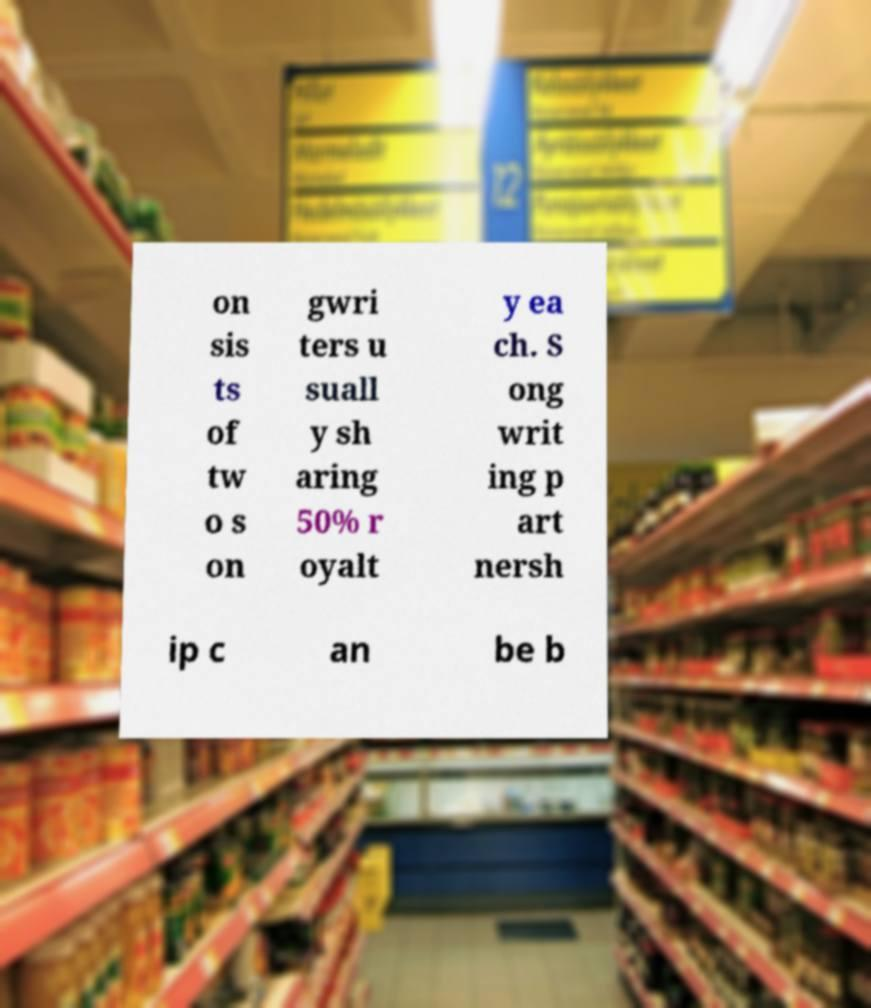What messages or text are displayed in this image? I need them in a readable, typed format. on sis ts of tw o s on gwri ters u suall y sh aring 50% r oyalt y ea ch. S ong writ ing p art nersh ip c an be b 